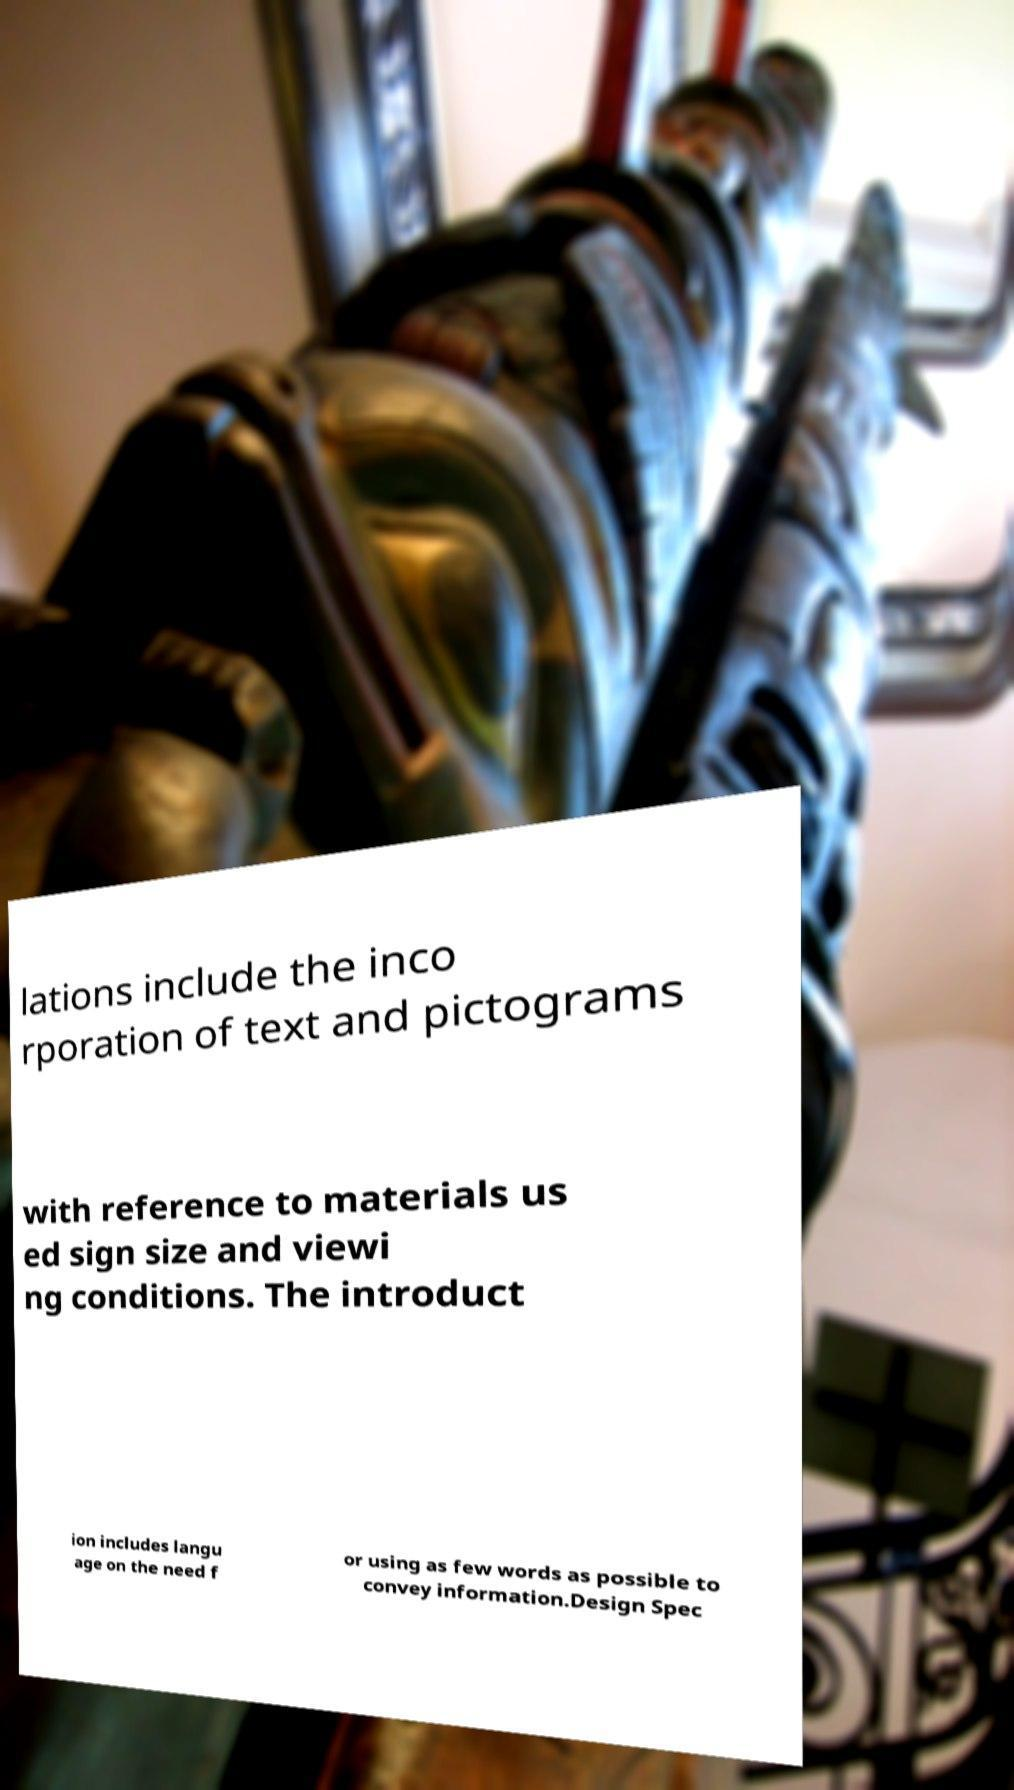What messages or text are displayed in this image? I need them in a readable, typed format. lations include the inco rporation of text and pictograms with reference to materials us ed sign size and viewi ng conditions. The introduct ion includes langu age on the need f or using as few words as possible to convey information.Design Spec 